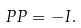Convert formula to latex. <formula><loc_0><loc_0><loc_500><loc_500>P P = - { I } .</formula> 